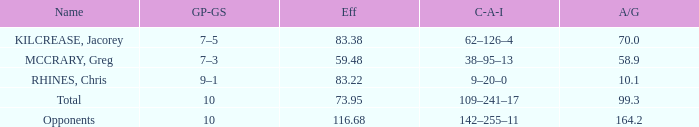What is the avg/g of Rhines, Chris, who has an effic greater than 73.95? 10.1. 